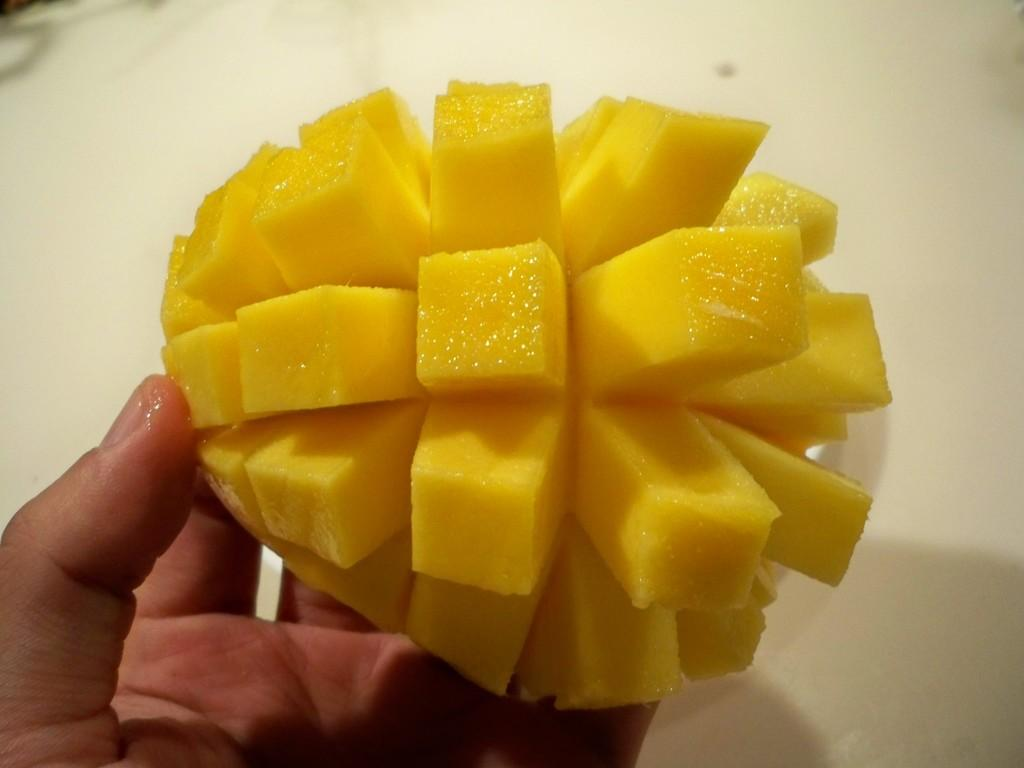What part of the human body is visible in the image? There is a human hand in the image. What type of fruit can be seen in the image? There are slices of mango in the image. How much salt is sprinkled on the mango slices in the image? There is no salt present in the image; it only shows slices of mango and a human hand. 